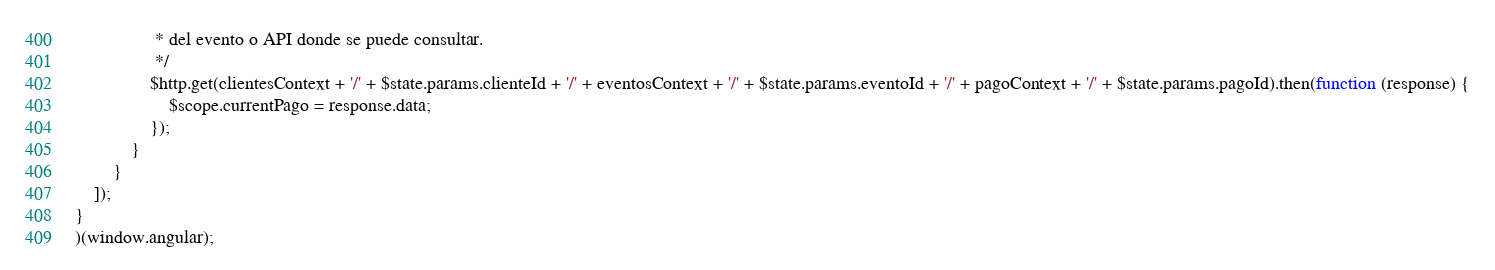Convert code to text. <code><loc_0><loc_0><loc_500><loc_500><_JavaScript_>                 * del evento o API donde se puede consultar.
                 */
                $http.get(clientesContext + '/' + $state.params.clienteId + '/' + eventosContext + '/' + $state.params.eventoId + '/' + pagoContext + '/' + $state.params.pagoId).then(function (response) {
                    $scope.currentPago = response.data;
                });
            }
        }
    ]);
}
)(window.angular);</code> 